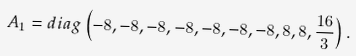<formula> <loc_0><loc_0><loc_500><loc_500>A _ { 1 } = d i a g \left ( - 8 , - 8 , - 8 , - 8 , - 8 , - 8 , - 8 , 8 , 8 , \frac { 1 6 } { 3 } \right ) .</formula> 